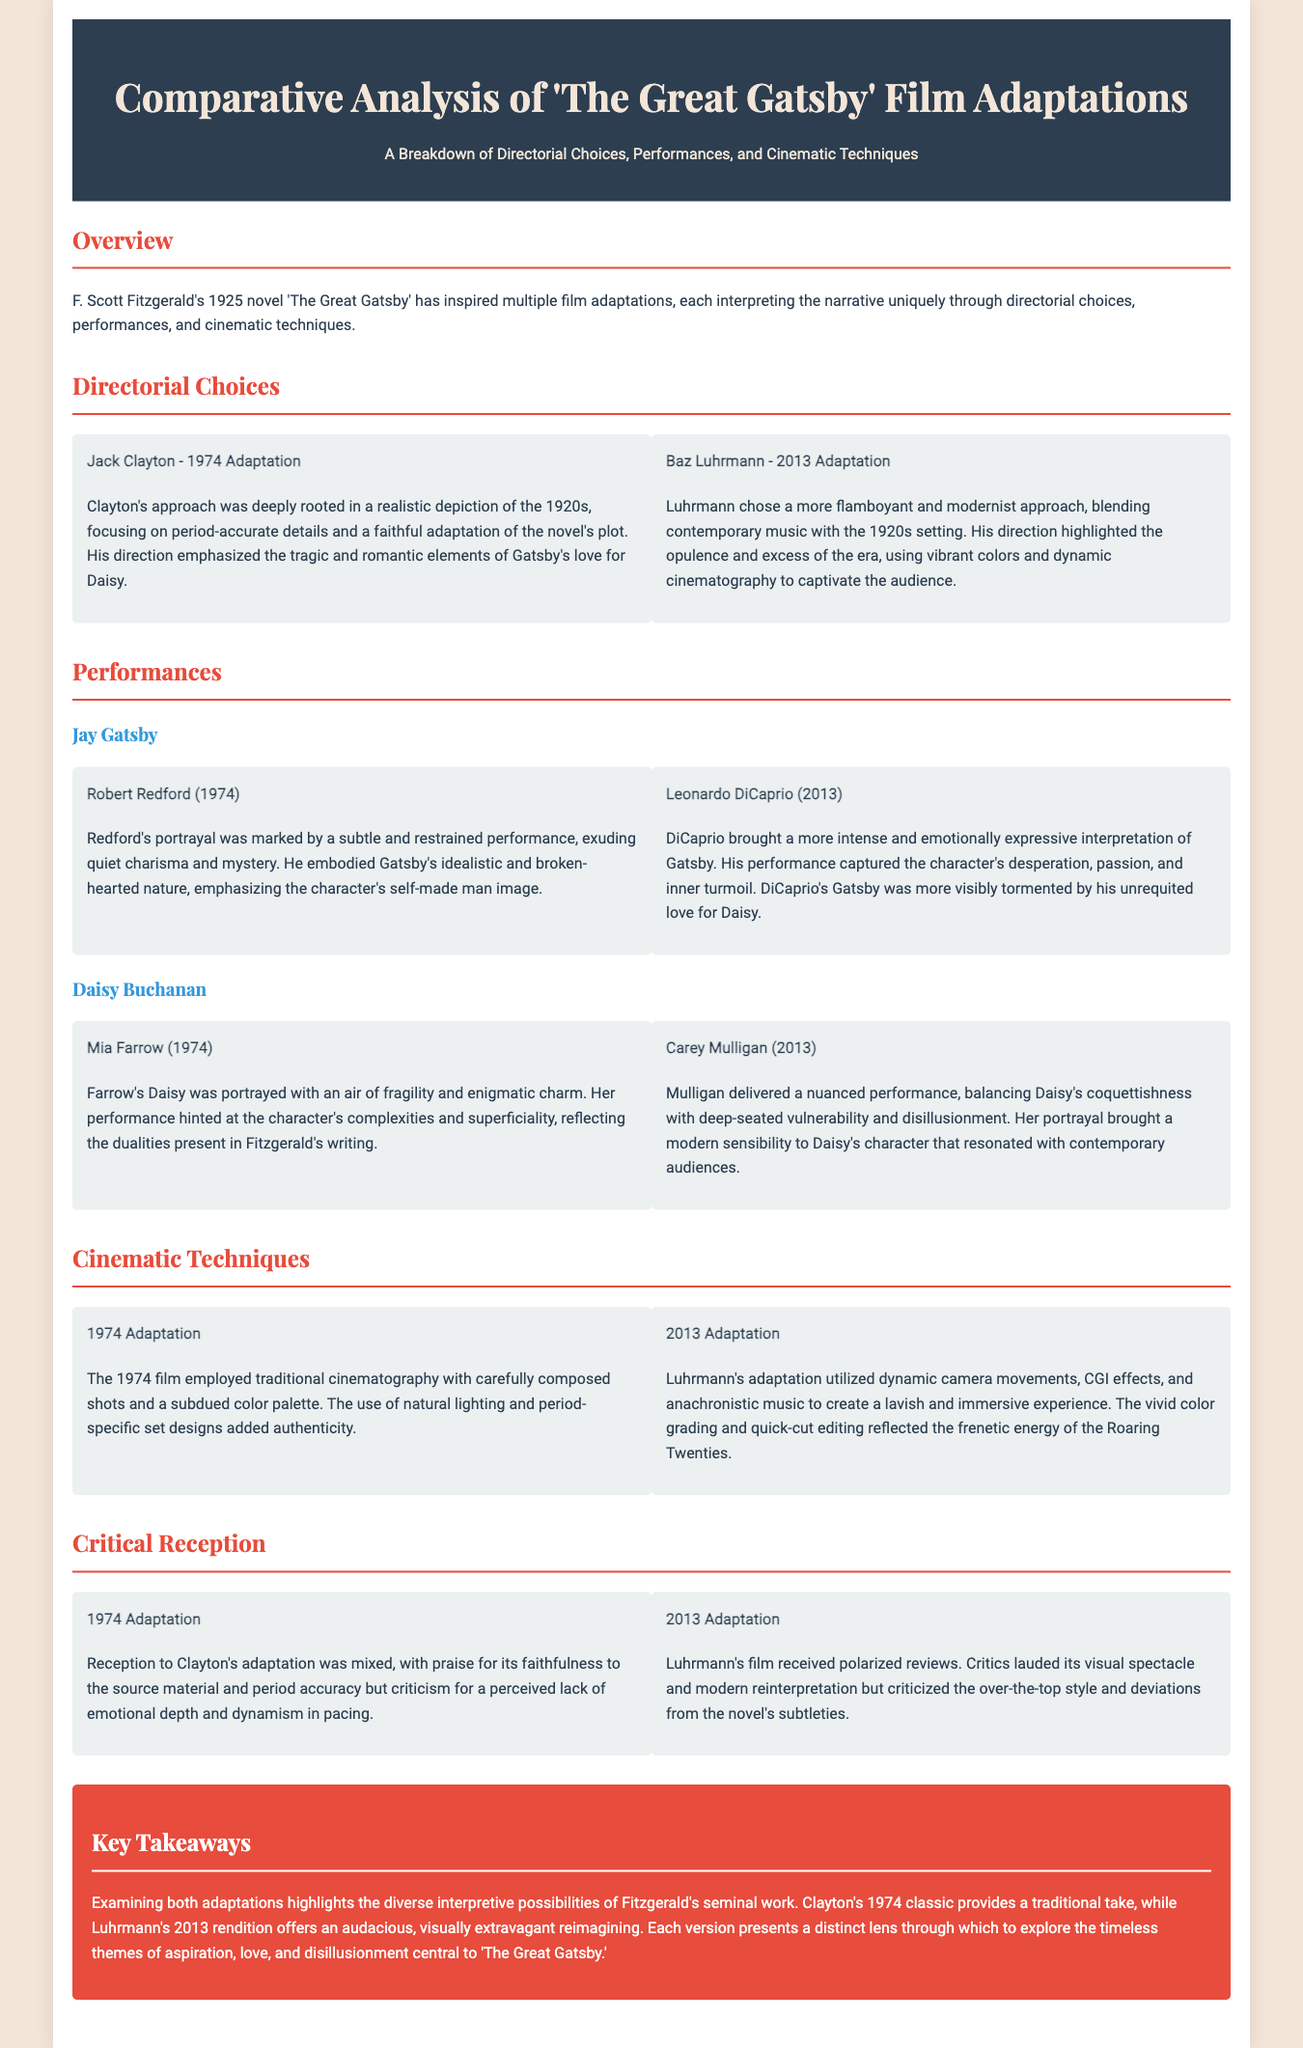what year was the original novel published? The document states that F. Scott Fitzgerald's novel 'The Great Gatsby' was published in 1925.
Answer: 1925 who directed the 2013 adaptation of 'The Great Gatsby'? The document specifies that Baz Luhrmann directed the 2013 adaptation.
Answer: Baz Luhrmann which actor played Jay Gatsby in the 1974 film? The document mentions that Robert Redford portrayed Jay Gatsby in the 1974 adaptation.
Answer: Robert Redford how did the 2013 adaptation differ in cinematic techniques compared to the 1974 one? The document details that the 2013 adaptation utilized dynamic camera movements and CGI effects, while the 1974 adaptation used traditional cinematography with a subdued color palette.
Answer: Dynamic camera movements and CGI effects what was a major criticism of the 1974 adaptation? According to the document, a major criticism was for a perceived lack of emotional depth and dynamism in pacing.
Answer: Lack of emotional depth how did Carey Mulligan's performance as Daisy Buchanan differ from Mia Farrow's? The document describes Mulligan's performance as nuanced and balancing vulnerability, while Farrow's portrayal had an air of fragility and enigmatic charm.
Answer: Nuanced and vulnerable which adaptation's thematic lens emphasizes opulence and excess? The document states that Baz Luhrmann's 2013 adaptation emphasizes opulence and excess in its thematic lens.
Answer: 2013 adaptation what is the key takeaway regarding both adaptations? The document concludes that both adaptations provide diverse interpretive possibilities of Fitzgerald’s work, with Clayton's being traditional and Luhrmann's being visually extravagant.
Answer: Diverse interpretive possibilities 